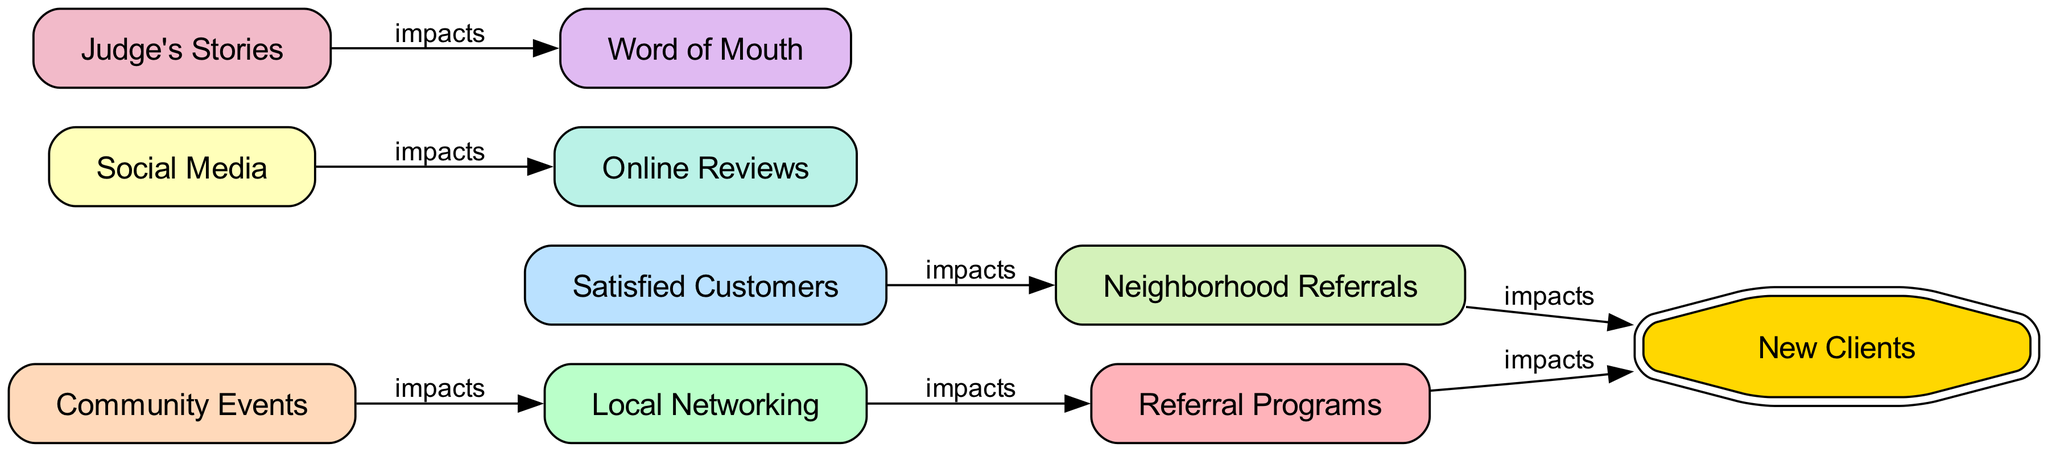What are the main referral sources for new client acquisition? The nodes that represent referral sources in the diagram are: Referral Programs, Local Networking, Satisfied Customers, Social Media, Community Events, Word of Mouth, Online Reviews, and Judge's Stories.
Answer: Referral Programs, Local Networking, Satisfied Customers, Social Media, Community Events, Word of Mouth, Online Reviews, Judge's Stories How many nodes are present in the diagram? The diagram includes a total of 9 nodes which are: Referral Programs, Local Networking, Satisfied Customers, Social Media, Community Events, Word of Mouth, Online Reviews, Judge's Stories, and New Clients.
Answer: 9 What impact do satisfied customers have according to the diagram? Satisfied Customers lead to Neighborhood Referrals, which directly impacts New Clients. This indicates that positive experiences encourage existing clients to refer new clients.
Answer: Neighborhood Referrals Which referral source leads directly to new clients? There are two sources that lead directly to New Clients in the diagram: Referral Programs and Neighborhood Referrals.
Answer: Referral Programs, Neighborhood Referrals How do community events influence networking? Community Events impact Local Networking directly, suggesting that participating in community activities helps strengthen networking opportunities for freelancers.
Answer: Local Networking What relationship does word of mouth have with other sources? Word of Mouth is influenced by Judge's Stories, indicating that stories shared by a judge can enhance the likelihood of referrals through word of mouth among potential clients.
Answer: Judge's Stories How many edges are displayed in the directed graph? The diagram consists of 6 directed edges that show the impact flow between the nodes, indicating how one source affects another in acquiring new clients.
Answer: 6 Which nodes lead to new clients through direct connections? The nodes that connect directly to New Clients, indicating a direct influence, include Referral Programs and Neighborhood Referrals.
Answer: Referral Programs, Neighborhood Referrals What is the role of social media in this graph? Social Media has a direct impact on Online Reviews, which can affect the overall perception and reputation of a freelancer, potentially leading to new clients.
Answer: Online Reviews 